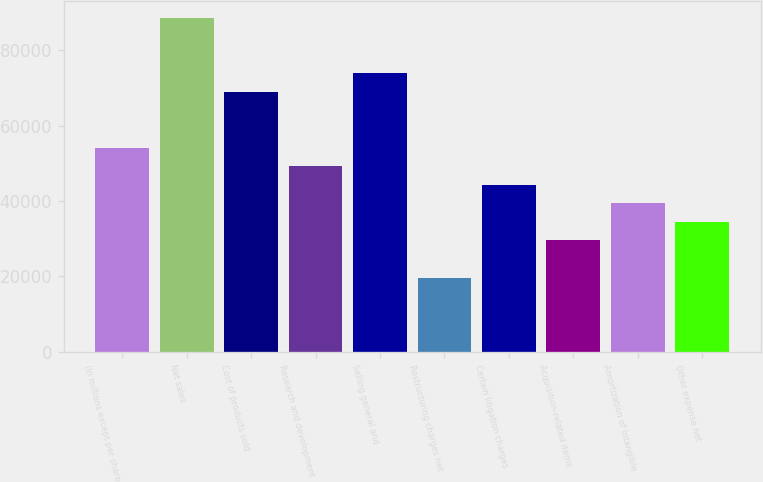<chart> <loc_0><loc_0><loc_500><loc_500><bar_chart><fcel>(in millions except per share<fcel>Net sales<fcel>Cost of products sold<fcel>Research and development<fcel>Selling general and<fcel>Restructuring charges net<fcel>Certain litigation charges<fcel>Acquisition-related items<fcel>Amortization of intangible<fcel>Other expense net<nl><fcel>54171.6<fcel>88643.7<fcel>68945.4<fcel>49247<fcel>73870<fcel>19699.5<fcel>44322.4<fcel>29548.7<fcel>39397.8<fcel>34473.2<nl></chart> 